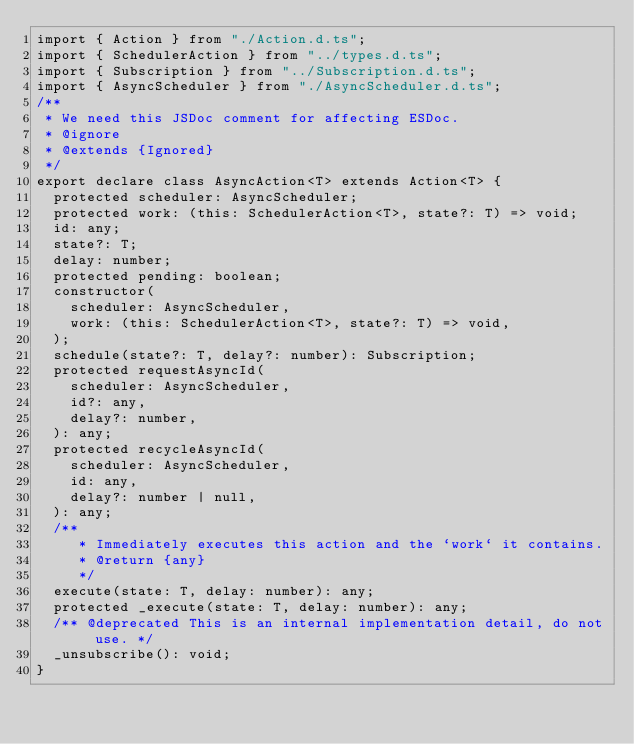Convert code to text. <code><loc_0><loc_0><loc_500><loc_500><_TypeScript_>import { Action } from "./Action.d.ts";
import { SchedulerAction } from "../types.d.ts";
import { Subscription } from "../Subscription.d.ts";
import { AsyncScheduler } from "./AsyncScheduler.d.ts";
/**
 * We need this JSDoc comment for affecting ESDoc.
 * @ignore
 * @extends {Ignored}
 */
export declare class AsyncAction<T> extends Action<T> {
  protected scheduler: AsyncScheduler;
  protected work: (this: SchedulerAction<T>, state?: T) => void;
  id: any;
  state?: T;
  delay: number;
  protected pending: boolean;
  constructor(
    scheduler: AsyncScheduler,
    work: (this: SchedulerAction<T>, state?: T) => void,
  );
  schedule(state?: T, delay?: number): Subscription;
  protected requestAsyncId(
    scheduler: AsyncScheduler,
    id?: any,
    delay?: number,
  ): any;
  protected recycleAsyncId(
    scheduler: AsyncScheduler,
    id: any,
    delay?: number | null,
  ): any;
  /**
     * Immediately executes this action and the `work` it contains.
     * @return {any}
     */
  execute(state: T, delay: number): any;
  protected _execute(state: T, delay: number): any;
  /** @deprecated This is an internal implementation detail, do not use. */
  _unsubscribe(): void;
}
</code> 